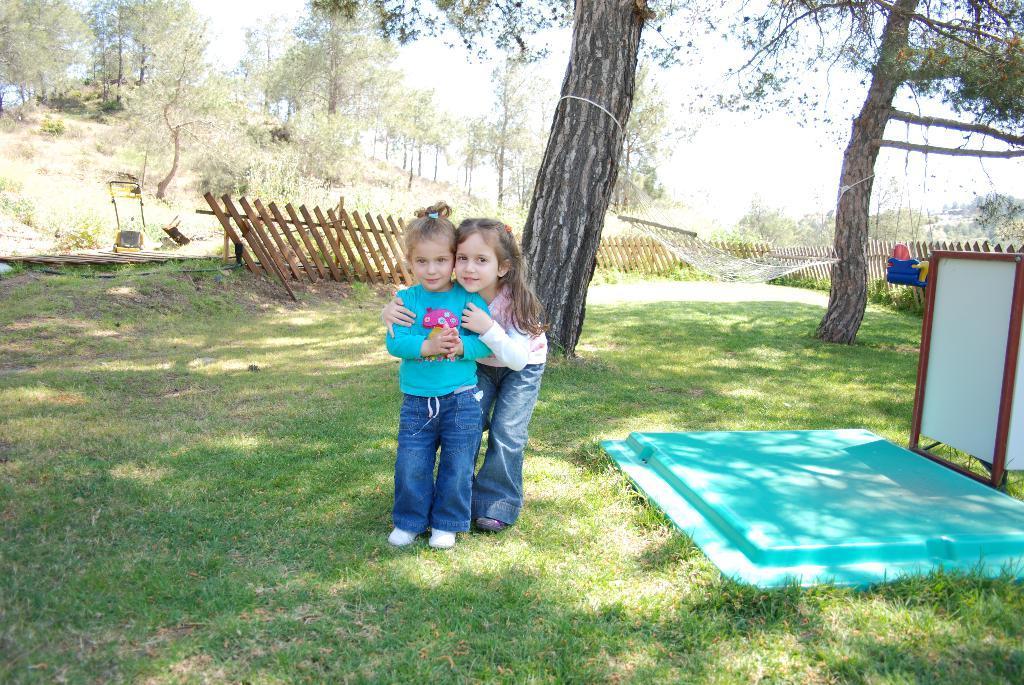In one or two sentences, can you explain what this image depicts? In the center of the image we can see two girls standing. There is a fence. In the background we can see trees and sky. On the right there is an object. At the bottom there is grass. 